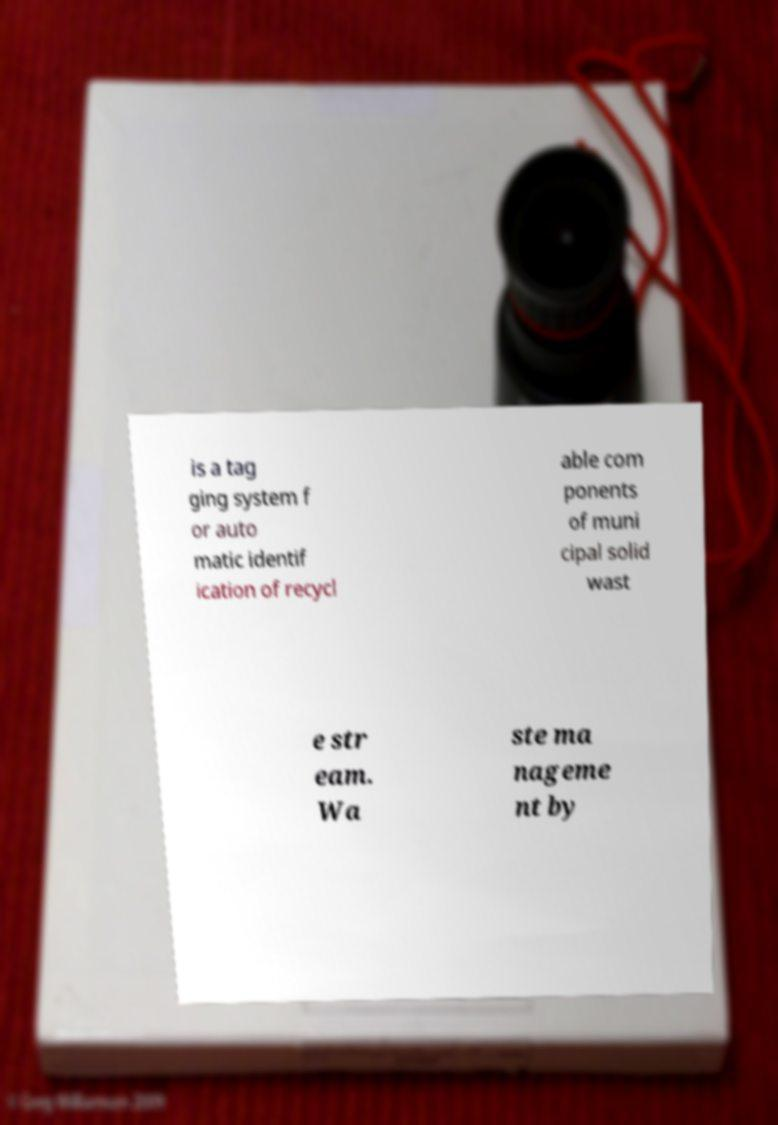I need the written content from this picture converted into text. Can you do that? is a tag ging system f or auto matic identif ication of recycl able com ponents of muni cipal solid wast e str eam. Wa ste ma nageme nt by 